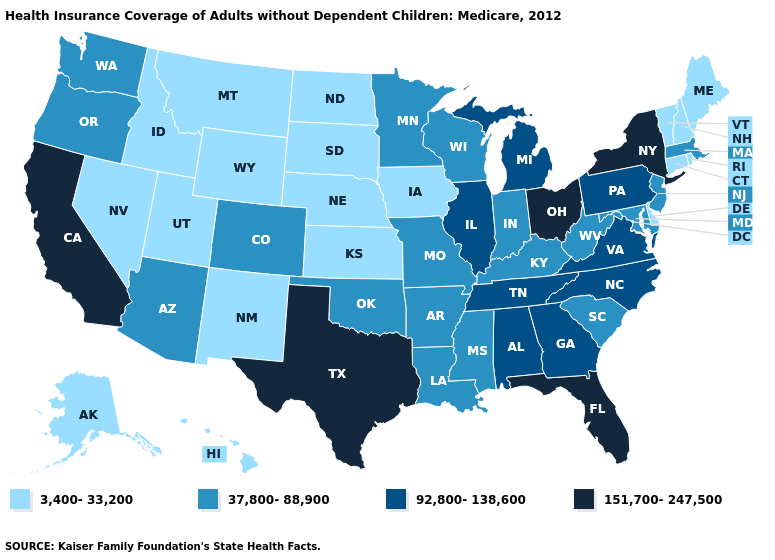Does Florida have the highest value in the USA?
Write a very short answer. Yes. Name the states that have a value in the range 37,800-88,900?
Answer briefly. Arizona, Arkansas, Colorado, Indiana, Kentucky, Louisiana, Maryland, Massachusetts, Minnesota, Mississippi, Missouri, New Jersey, Oklahoma, Oregon, South Carolina, Washington, West Virginia, Wisconsin. Which states have the highest value in the USA?
Be succinct. California, Florida, New York, Ohio, Texas. Which states have the highest value in the USA?
Keep it brief. California, Florida, New York, Ohio, Texas. Does Nevada have the lowest value in the West?
Be succinct. Yes. Among the states that border Texas , does Louisiana have the highest value?
Short answer required. Yes. Does North Dakota have the same value as Delaware?
Answer briefly. Yes. Does the map have missing data?
Give a very brief answer. No. Among the states that border Arizona , which have the lowest value?
Give a very brief answer. Nevada, New Mexico, Utah. Among the states that border Maryland , does Virginia have the highest value?
Be succinct. Yes. Name the states that have a value in the range 3,400-33,200?
Answer briefly. Alaska, Connecticut, Delaware, Hawaii, Idaho, Iowa, Kansas, Maine, Montana, Nebraska, Nevada, New Hampshire, New Mexico, North Dakota, Rhode Island, South Dakota, Utah, Vermont, Wyoming. Name the states that have a value in the range 37,800-88,900?
Short answer required. Arizona, Arkansas, Colorado, Indiana, Kentucky, Louisiana, Maryland, Massachusetts, Minnesota, Mississippi, Missouri, New Jersey, Oklahoma, Oregon, South Carolina, Washington, West Virginia, Wisconsin. Name the states that have a value in the range 92,800-138,600?
Keep it brief. Alabama, Georgia, Illinois, Michigan, North Carolina, Pennsylvania, Tennessee, Virginia. Name the states that have a value in the range 3,400-33,200?
Quick response, please. Alaska, Connecticut, Delaware, Hawaii, Idaho, Iowa, Kansas, Maine, Montana, Nebraska, Nevada, New Hampshire, New Mexico, North Dakota, Rhode Island, South Dakota, Utah, Vermont, Wyoming. What is the lowest value in the USA?
Quick response, please. 3,400-33,200. 